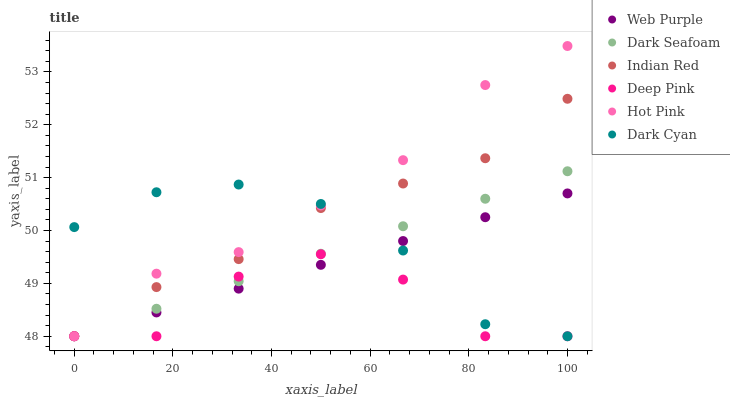Does Deep Pink have the minimum area under the curve?
Answer yes or no. Yes. Does Hot Pink have the maximum area under the curve?
Answer yes or no. Yes. Does Dark Seafoam have the minimum area under the curve?
Answer yes or no. No. Does Dark Seafoam have the maximum area under the curve?
Answer yes or no. No. Is Web Purple the smoothest?
Answer yes or no. Yes. Is Deep Pink the roughest?
Answer yes or no. Yes. Is Hot Pink the smoothest?
Answer yes or no. No. Is Hot Pink the roughest?
Answer yes or no. No. Does Deep Pink have the lowest value?
Answer yes or no. Yes. Does Hot Pink have the highest value?
Answer yes or no. Yes. Does Dark Seafoam have the highest value?
Answer yes or no. No. Does Indian Red intersect Hot Pink?
Answer yes or no. Yes. Is Indian Red less than Hot Pink?
Answer yes or no. No. Is Indian Red greater than Hot Pink?
Answer yes or no. No. 